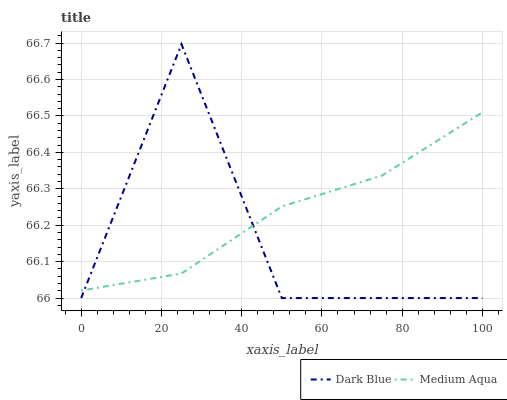Does Dark Blue have the minimum area under the curve?
Answer yes or no. Yes. Does Medium Aqua have the maximum area under the curve?
Answer yes or no. Yes. Does Medium Aqua have the minimum area under the curve?
Answer yes or no. No. Is Medium Aqua the smoothest?
Answer yes or no. Yes. Is Dark Blue the roughest?
Answer yes or no. Yes. Is Medium Aqua the roughest?
Answer yes or no. No. Does Dark Blue have the lowest value?
Answer yes or no. Yes. Does Medium Aqua have the lowest value?
Answer yes or no. No. Does Dark Blue have the highest value?
Answer yes or no. Yes. Does Medium Aqua have the highest value?
Answer yes or no. No. Does Dark Blue intersect Medium Aqua?
Answer yes or no. Yes. Is Dark Blue less than Medium Aqua?
Answer yes or no. No. Is Dark Blue greater than Medium Aqua?
Answer yes or no. No. 